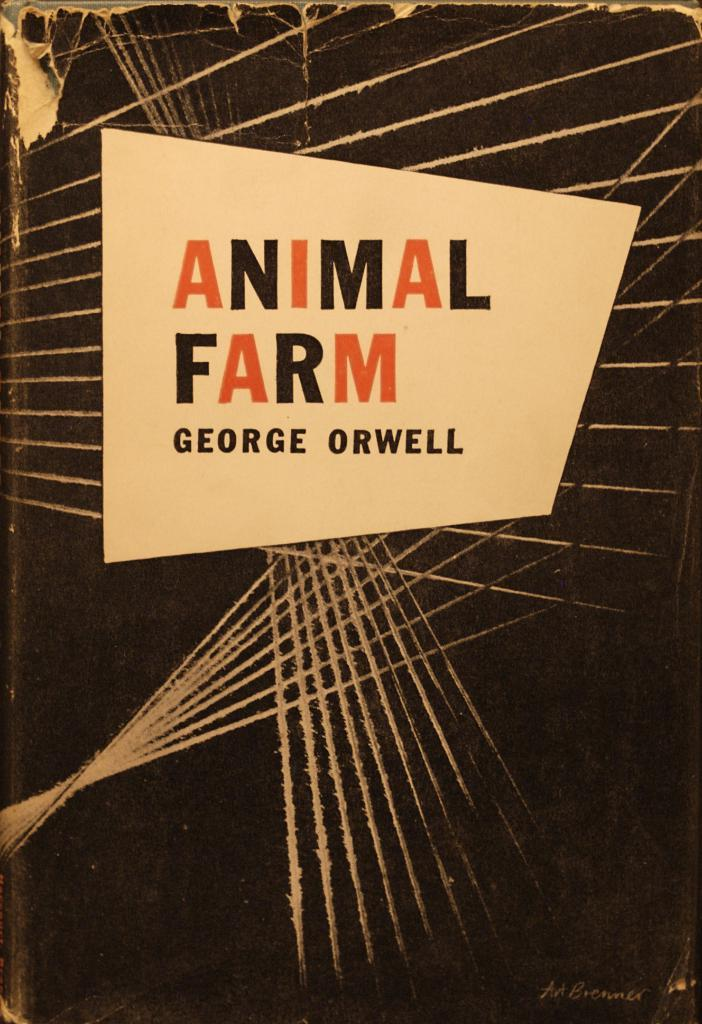<image>
Offer a succinct explanation of the picture presented. a book cover of the book animal farm by george orwell 